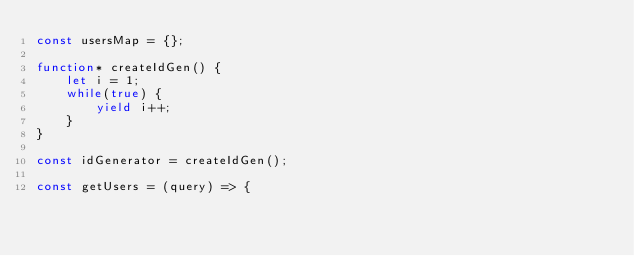Convert code to text. <code><loc_0><loc_0><loc_500><loc_500><_JavaScript_>const usersMap = {};

function* createIdGen() {
    let i = 1;
    while(true) {
        yield i++;
    }
}

const idGenerator = createIdGen();

const getUsers = (query) => {</code> 